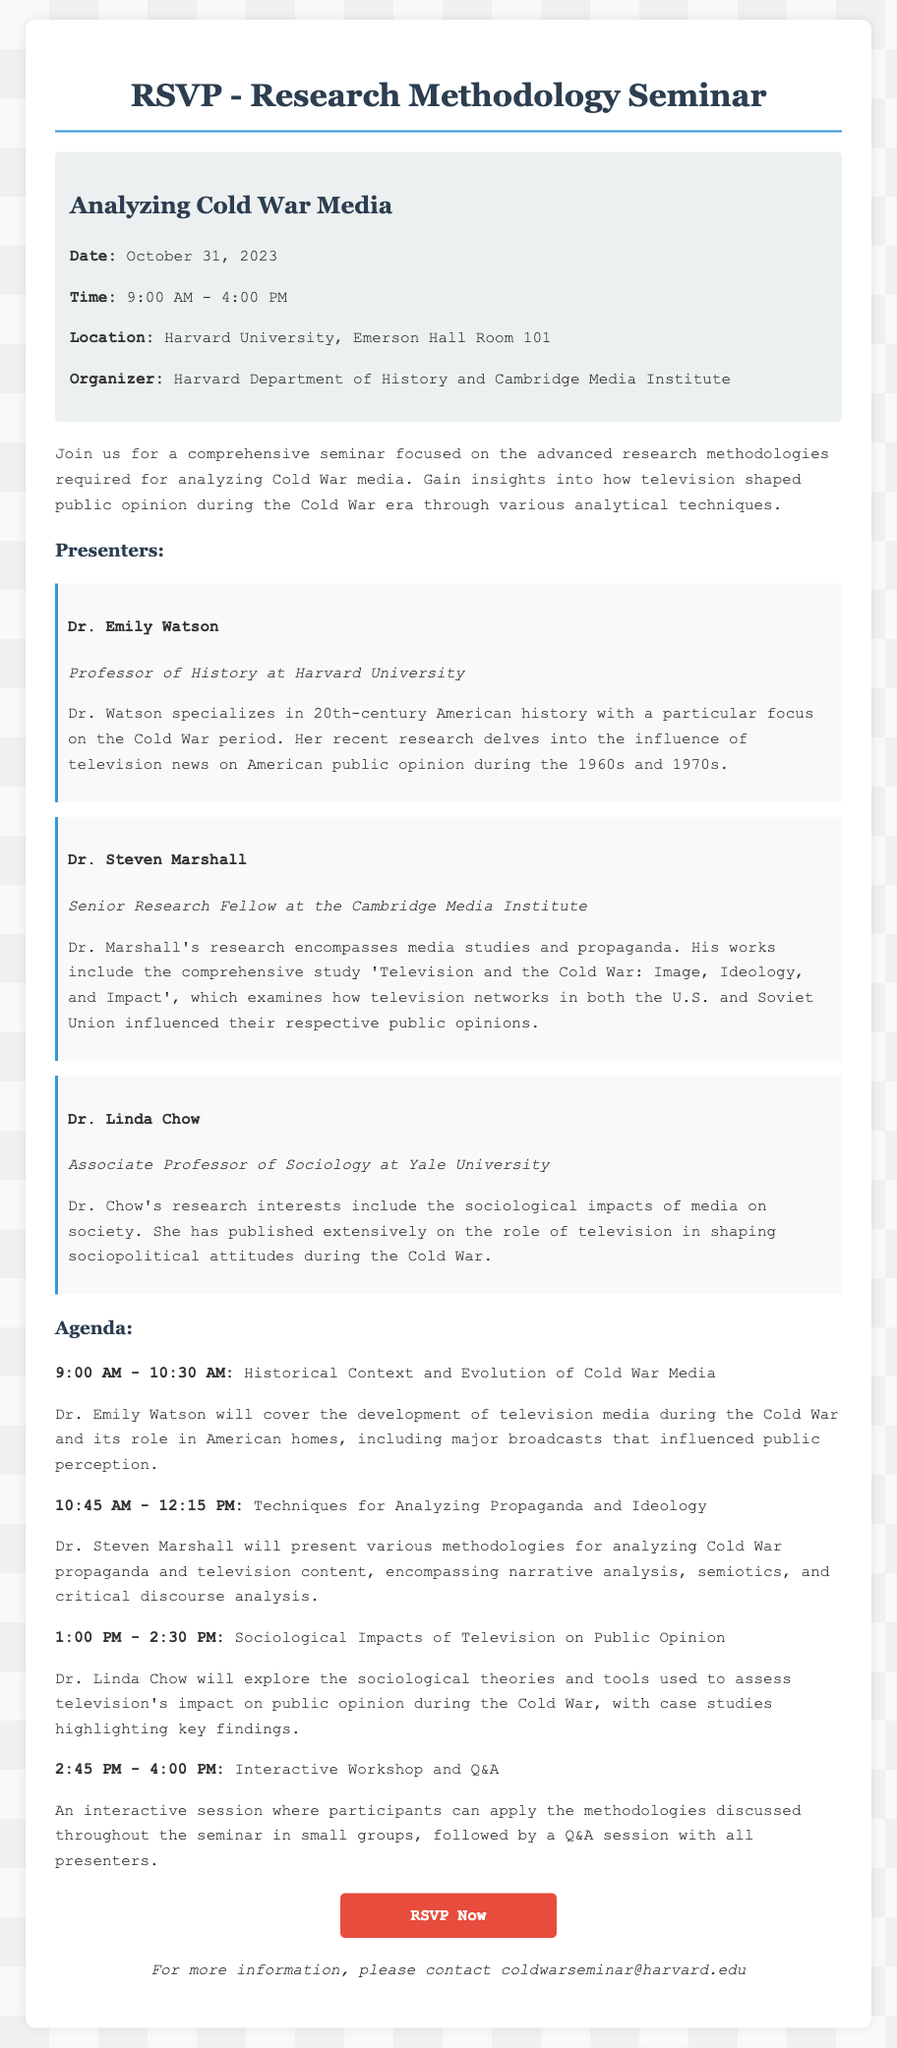What is the date of the seminar? The date of the seminar is explicitly stated in the document under event details.
Answer: October 31, 2023 Who is the first presenter? The first presenter is mentioned in the section detailing presenters.
Answer: Dr. Emily Watson What is the main topic of the seminar? The main topic is highlighted in the seminar title.
Answer: Analyzing Cold War Media What are the seminar hours? The start and end times of the seminar can be found in the event details.
Answer: 9:00 AM - 4:00 PM What institution is organizing the seminar? The organizing institutions are listed in the event details.
Answer: Harvard Department of History and Cambridge Media Institute What is Dr. Steven Marshall's role? Dr. Steven Marshall's role is outlined in his presenter bio.
Answer: Senior Research Fellow What session starts at 1:00 PM? The agenda specifies sessions with corresponding times listed.
Answer: Sociological Impacts of Television on Public Opinion What type of activities are included in the interactive session? The document describes the nature of the interactive session in the agenda.
Answer: Applying methodologies in small groups What is the RSVP link provided in the document? The RSVP link is presented towards the end of the document, directing participants on how to respond.
Answer: http://harvard.edu/coldwarseminar/rsvp 